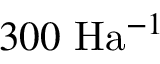<formula> <loc_0><loc_0><loc_500><loc_500>3 0 0 \ H a ^ { - 1 }</formula> 